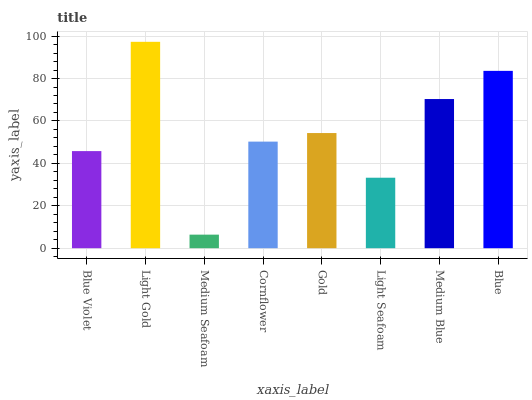Is Medium Seafoam the minimum?
Answer yes or no. Yes. Is Light Gold the maximum?
Answer yes or no. Yes. Is Light Gold the minimum?
Answer yes or no. No. Is Medium Seafoam the maximum?
Answer yes or no. No. Is Light Gold greater than Medium Seafoam?
Answer yes or no. Yes. Is Medium Seafoam less than Light Gold?
Answer yes or no. Yes. Is Medium Seafoam greater than Light Gold?
Answer yes or no. No. Is Light Gold less than Medium Seafoam?
Answer yes or no. No. Is Gold the high median?
Answer yes or no. Yes. Is Cornflower the low median?
Answer yes or no. Yes. Is Medium Seafoam the high median?
Answer yes or no. No. Is Gold the low median?
Answer yes or no. No. 